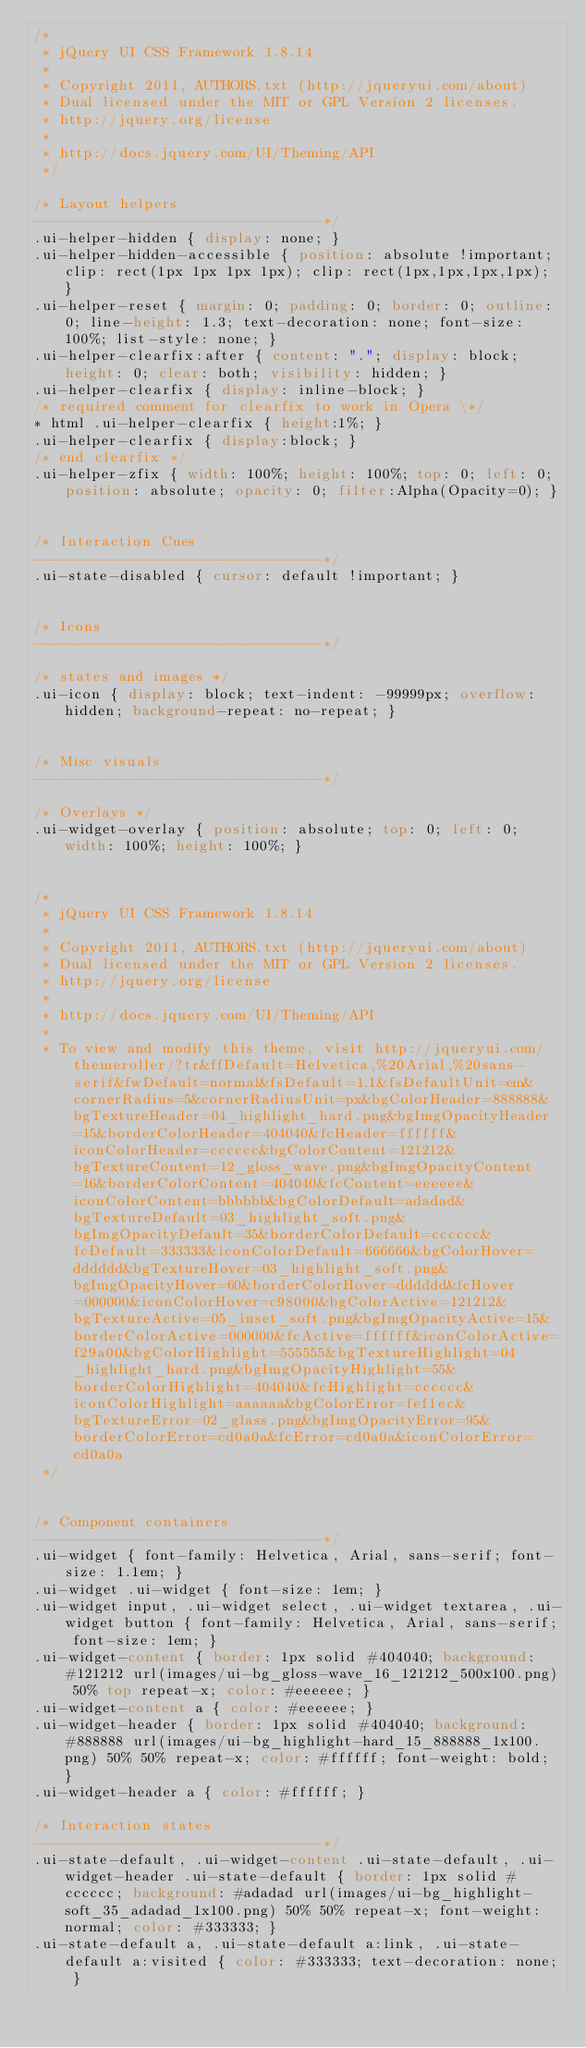<code> <loc_0><loc_0><loc_500><loc_500><_CSS_>/*
 * jQuery UI CSS Framework 1.8.14
 *
 * Copyright 2011, AUTHORS.txt (http://jqueryui.com/about)
 * Dual licensed under the MIT or GPL Version 2 licenses.
 * http://jquery.org/license
 *
 * http://docs.jquery.com/UI/Theming/API
 */

/* Layout helpers
----------------------------------*/
.ui-helper-hidden { display: none; }
.ui-helper-hidden-accessible { position: absolute !important; clip: rect(1px 1px 1px 1px); clip: rect(1px,1px,1px,1px); }
.ui-helper-reset { margin: 0; padding: 0; border: 0; outline: 0; line-height: 1.3; text-decoration: none; font-size: 100%; list-style: none; }
.ui-helper-clearfix:after { content: "."; display: block; height: 0; clear: both; visibility: hidden; }
.ui-helper-clearfix { display: inline-block; }
/* required comment for clearfix to work in Opera \*/
* html .ui-helper-clearfix { height:1%; }
.ui-helper-clearfix { display:block; }
/* end clearfix */
.ui-helper-zfix { width: 100%; height: 100%; top: 0; left: 0; position: absolute; opacity: 0; filter:Alpha(Opacity=0); }


/* Interaction Cues
----------------------------------*/
.ui-state-disabled { cursor: default !important; }


/* Icons
----------------------------------*/

/* states and images */
.ui-icon { display: block; text-indent: -99999px; overflow: hidden; background-repeat: no-repeat; }


/* Misc visuals
----------------------------------*/

/* Overlays */
.ui-widget-overlay { position: absolute; top: 0; left: 0; width: 100%; height: 100%; }


/*
 * jQuery UI CSS Framework 1.8.14
 *
 * Copyright 2011, AUTHORS.txt (http://jqueryui.com/about)
 * Dual licensed under the MIT or GPL Version 2 licenses.
 * http://jquery.org/license
 *
 * http://docs.jquery.com/UI/Theming/API
 *
 * To view and modify this theme, visit http://jqueryui.com/themeroller/?tr&ffDefault=Helvetica,%20Arial,%20sans-serif&fwDefault=normal&fsDefault=1.1&fsDefaultUnit=em&cornerRadius=5&cornerRadiusUnit=px&bgColorHeader=888888&bgTextureHeader=04_highlight_hard.png&bgImgOpacityHeader=15&borderColorHeader=404040&fcHeader=ffffff&iconColorHeader=cccccc&bgColorContent=121212&bgTextureContent=12_gloss_wave.png&bgImgOpacityContent=16&borderColorContent=404040&fcContent=eeeeee&iconColorContent=bbbbbb&bgColorDefault=adadad&bgTextureDefault=03_highlight_soft.png&bgImgOpacityDefault=35&borderColorDefault=cccccc&fcDefault=333333&iconColorDefault=666666&bgColorHover=dddddd&bgTextureHover=03_highlight_soft.png&bgImgOpacityHover=60&borderColorHover=dddddd&fcHover=000000&iconColorHover=c98000&bgColorActive=121212&bgTextureActive=05_inset_soft.png&bgImgOpacityActive=15&borderColorActive=000000&fcActive=ffffff&iconColorActive=f29a00&bgColorHighlight=555555&bgTextureHighlight=04_highlight_hard.png&bgImgOpacityHighlight=55&borderColorHighlight=404040&fcHighlight=cccccc&iconColorHighlight=aaaaaa&bgColorError=fef1ec&bgTextureError=02_glass.png&bgImgOpacityError=95&borderColorError=cd0a0a&fcError=cd0a0a&iconColorError=cd0a0a
 */


/* Component containers
----------------------------------*/
.ui-widget { font-family: Helvetica, Arial, sans-serif; font-size: 1.1em; }
.ui-widget .ui-widget { font-size: 1em; }
.ui-widget input, .ui-widget select, .ui-widget textarea, .ui-widget button { font-family: Helvetica, Arial, sans-serif; font-size: 1em; }
.ui-widget-content { border: 1px solid #404040; background: #121212 url(images/ui-bg_gloss-wave_16_121212_500x100.png) 50% top repeat-x; color: #eeeeee; }
.ui-widget-content a { color: #eeeeee; }
.ui-widget-header { border: 1px solid #404040; background: #888888 url(images/ui-bg_highlight-hard_15_888888_1x100.png) 50% 50% repeat-x; color: #ffffff; font-weight: bold; }
.ui-widget-header a { color: #ffffff; }

/* Interaction states
----------------------------------*/
.ui-state-default, .ui-widget-content .ui-state-default, .ui-widget-header .ui-state-default { border: 1px solid #cccccc; background: #adadad url(images/ui-bg_highlight-soft_35_adadad_1x100.png) 50% 50% repeat-x; font-weight: normal; color: #333333; }
.ui-state-default a, .ui-state-default a:link, .ui-state-default a:visited { color: #333333; text-decoration: none; }</code> 